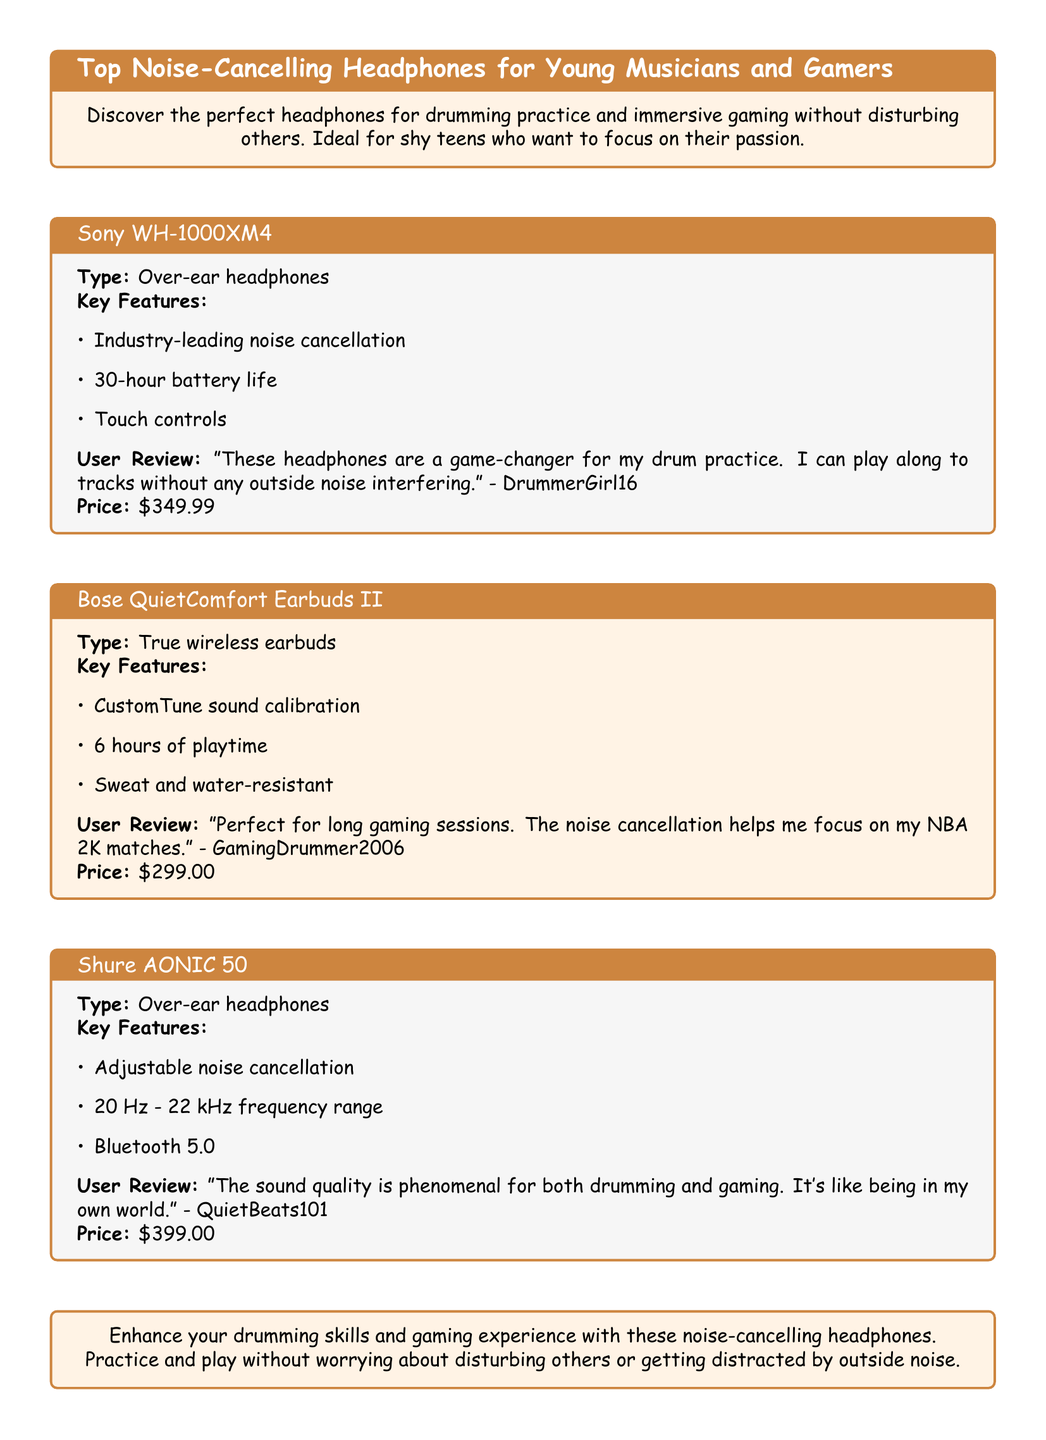What is the price of the Sony WH-1000XM4? The price of the Sony WH-1000XM4 is listed in the document.
Answer: $349.99 What type of headphones are the Bose QuietComfort Earbuds II? The type of the Bose QuietComfort Earbuds II is specified as true wireless earbuds in the document.
Answer: True wireless earbuds How long is the battery life of the Sony WH-1000XM4? The document states that the Sony WH-1000XM4 has a battery life of 30 hours.
Answer: 30 hours What feature of the Shure AONIC 50 is adjustable? There is a feature mentioned in the document regarding the Shure AONIC 50 that can be adjusted, which is the noise cancellation.
Answer: Noise cancellation Which user reviewed the Bose QuietComfort Earbuds II? The document includes a user review under the Bose QuietComfort Earbuds II section, indicating who reviewed it.
Answer: GamingDrummer2006 What is the frequency range of the Shure AONIC 50? The document provides the frequency range for the Shure AONIC 50, which can be found in its specifications.
Answer: 20 Hz - 22 kHz Which headphone model has touch controls? Touch controls are specifically mentioned in the features of one headphone model in the document.
Answer: Sony WH-1000XM4 What color is the background of the title box for the Bose QuietComfort Earbuds II? The document describes the color used for the background of the title box for the Bose QuietComfort Earbuds II.
Answer: Basketball Orange 